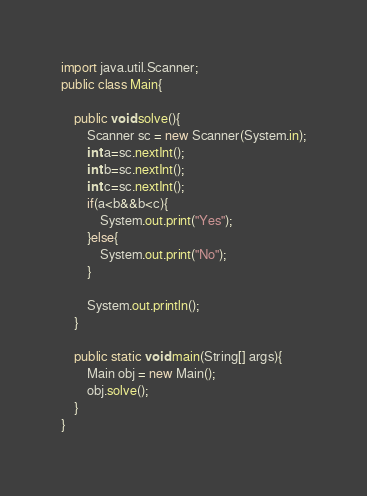<code> <loc_0><loc_0><loc_500><loc_500><_Java_>import java.util.Scanner;
public class Main{
    
    public void solve(){
        Scanner sc = new Scanner(System.in);
        int a=sc.nextInt();
        int b=sc.nextInt();
        int c=sc.nextInt();
        if(a<b&&b<c){
            System.out.print("Yes");
        }else{
            System.out.print("No");
        }
   
        System.out.println();
    }
    
    public static void main(String[] args){
        Main obj = new Main();
        obj.solve();
    }
}</code> 